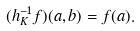<formula> <loc_0><loc_0><loc_500><loc_500>( h _ { K } ^ { - 1 } f ) ( a , b ) = f ( a ) .</formula> 